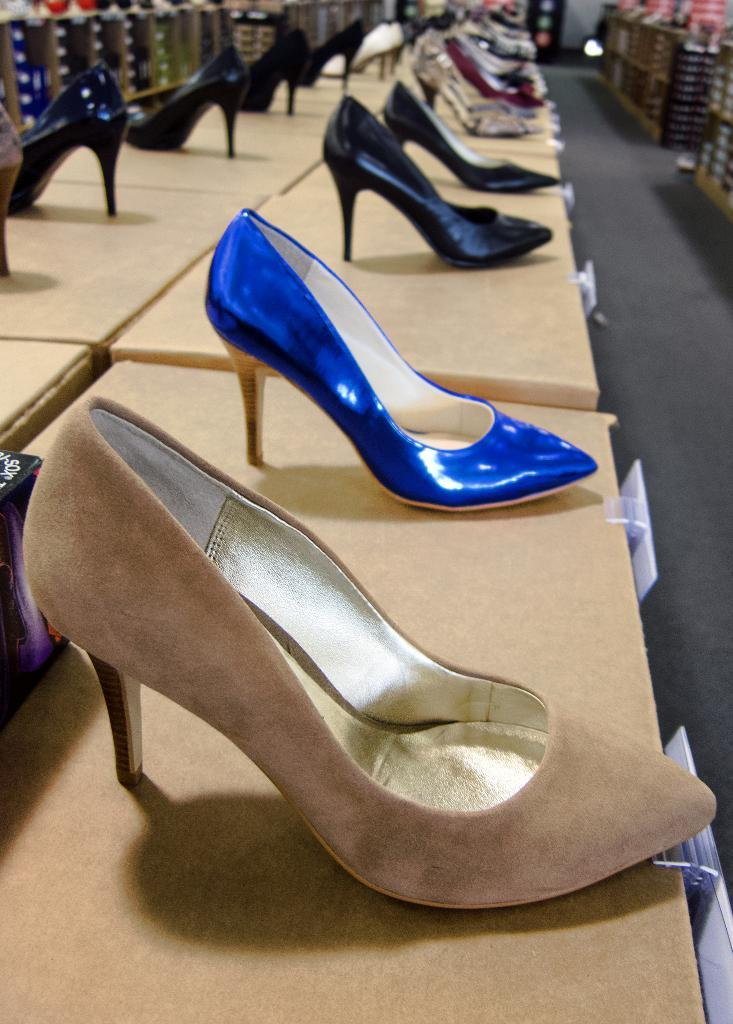What type of object is present in the image? There is footwear in the image. Can you describe the background of the image? The background of the image is blurry. What type of voyage is depicted in the image? There is no voyage depicted in the image; it only features footwear and a blurry background. What scent can be detected from the jar in the image? There is no jar present in the image, so it is not possible to determine any scent. 